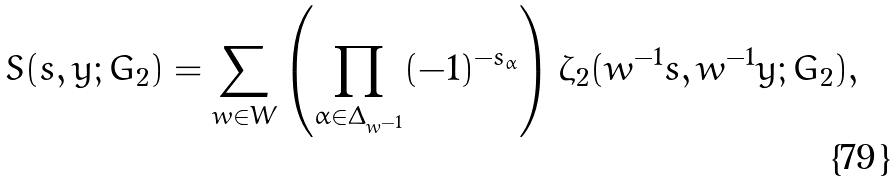Convert formula to latex. <formula><loc_0><loc_0><loc_500><loc_500>S ( s , y ; G _ { 2 } ) = \sum _ { w \in W } \left ( \prod _ { \alpha \in \Delta _ { w ^ { - 1 } } } ( - 1 ) ^ { - s _ { \alpha } } \right ) \zeta _ { 2 } ( w ^ { - 1 } s , w ^ { - 1 } y ; G _ { 2 } ) ,</formula> 